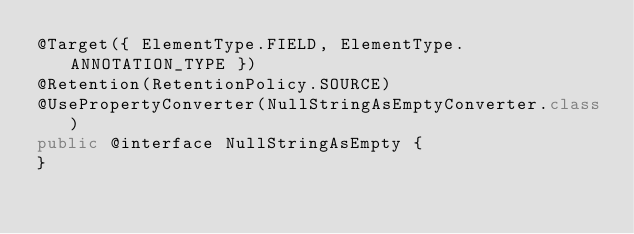<code> <loc_0><loc_0><loc_500><loc_500><_Java_>@Target({ ElementType.FIELD, ElementType.ANNOTATION_TYPE })
@Retention(RetentionPolicy.SOURCE)
@UsePropertyConverter(NullStringAsEmptyConverter.class)
public @interface NullStringAsEmpty {
}
</code> 